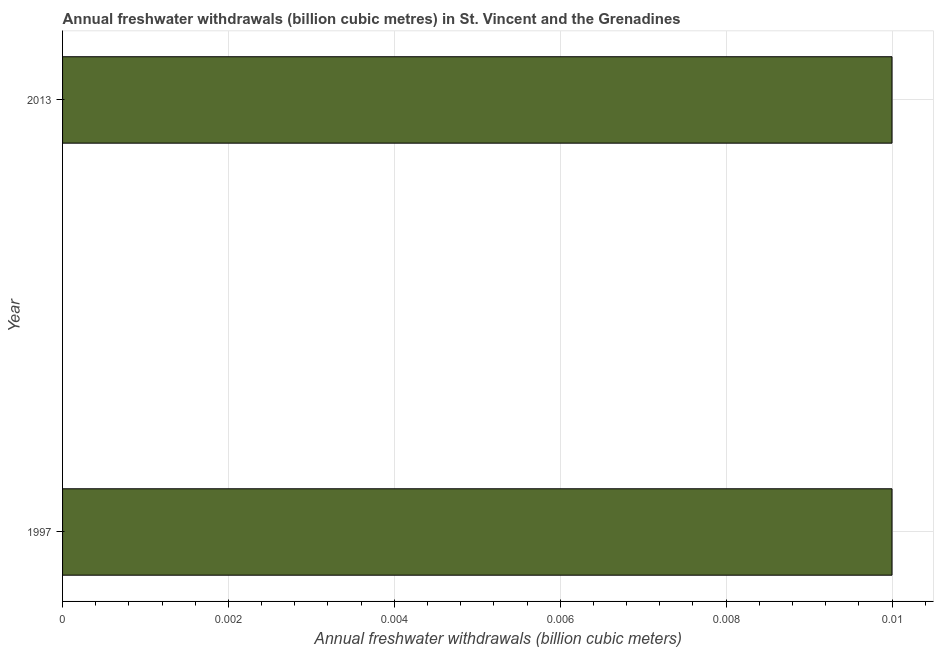What is the title of the graph?
Give a very brief answer. Annual freshwater withdrawals (billion cubic metres) in St. Vincent and the Grenadines. What is the label or title of the X-axis?
Make the answer very short. Annual freshwater withdrawals (billion cubic meters). What is the label or title of the Y-axis?
Offer a terse response. Year. What is the annual freshwater withdrawals in 2013?
Give a very brief answer. 0.01. Across all years, what is the minimum annual freshwater withdrawals?
Make the answer very short. 0.01. In which year was the annual freshwater withdrawals minimum?
Offer a terse response. 1997. What is the difference between the annual freshwater withdrawals in 1997 and 2013?
Ensure brevity in your answer.  0. What is the median annual freshwater withdrawals?
Provide a short and direct response. 0.01. Do a majority of the years between 1997 and 2013 (inclusive) have annual freshwater withdrawals greater than 0.0088 billion cubic meters?
Make the answer very short. Yes. What is the ratio of the annual freshwater withdrawals in 1997 to that in 2013?
Keep it short and to the point. 1. Is the annual freshwater withdrawals in 1997 less than that in 2013?
Your answer should be very brief. No. Are all the bars in the graph horizontal?
Give a very brief answer. Yes. How many years are there in the graph?
Provide a succinct answer. 2. What is the difference between two consecutive major ticks on the X-axis?
Your answer should be compact. 0. What is the Annual freshwater withdrawals (billion cubic meters) in 1997?
Provide a short and direct response. 0.01. What is the Annual freshwater withdrawals (billion cubic meters) of 2013?
Your answer should be very brief. 0.01. 